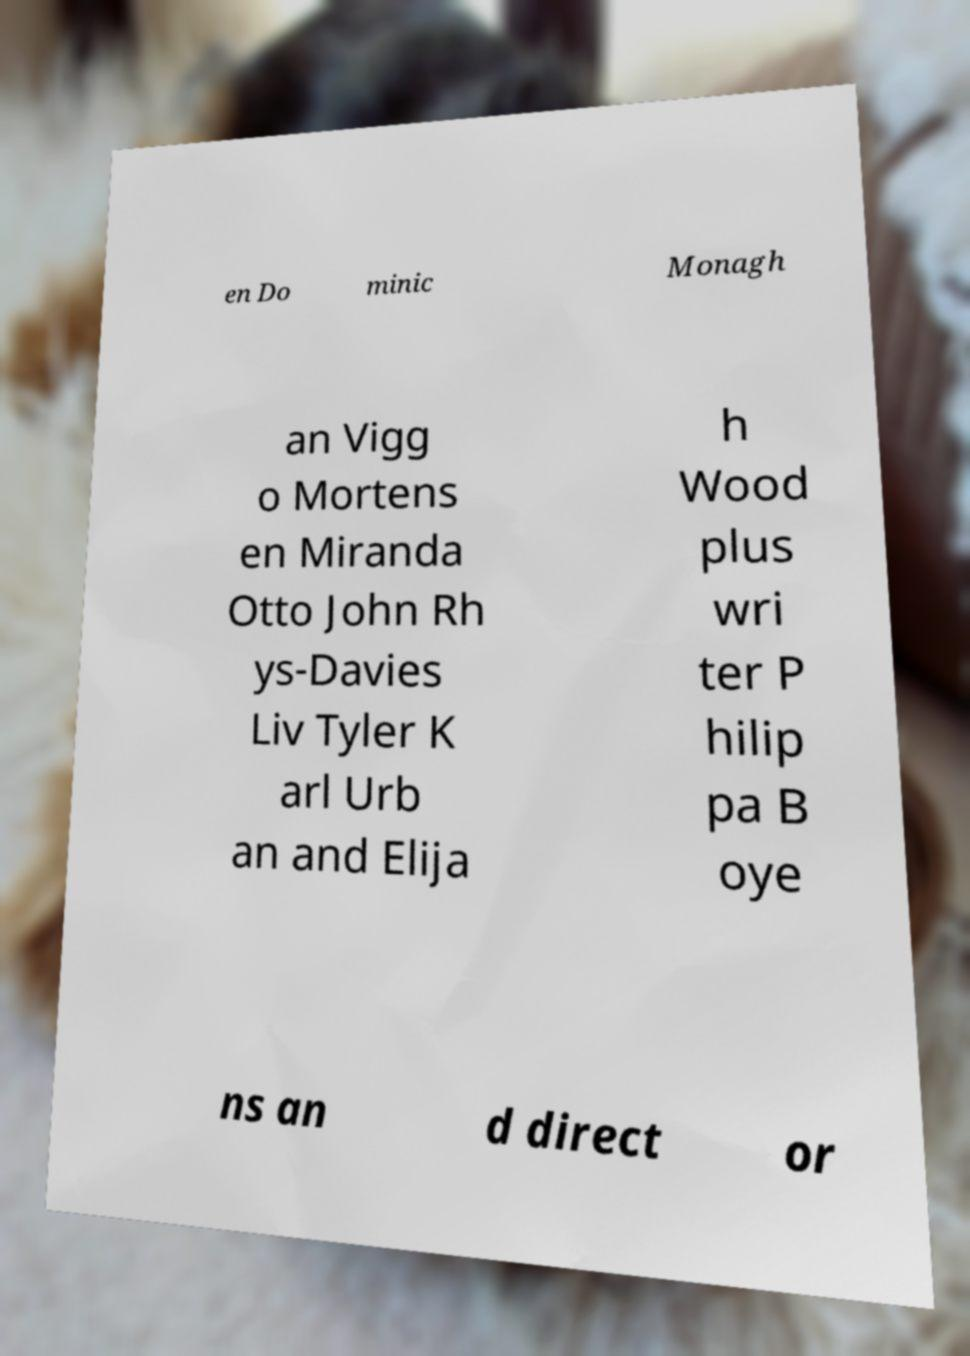Can you read and provide the text displayed in the image?This photo seems to have some interesting text. Can you extract and type it out for me? en Do minic Monagh an Vigg o Mortens en Miranda Otto John Rh ys-Davies Liv Tyler K arl Urb an and Elija h Wood plus wri ter P hilip pa B oye ns an d direct or 